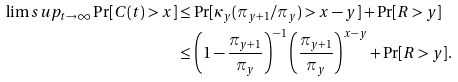<formula> <loc_0><loc_0><loc_500><loc_500>\lim s u p _ { t \to \infty } \Pr [ C ( t ) > x ] & \leq \Pr [ \kappa _ { y } ( \pi _ { y + 1 } / \pi _ { y } ) > x - y ] + \Pr [ R > y ] \\ & \leq \left ( 1 - \frac { \pi _ { y + 1 } } { \pi _ { y } } \right ) ^ { - 1 } \left ( \frac { \pi _ { y + 1 } } { \pi _ { y } } \right ) ^ { x - y } + \Pr [ R > y ] .</formula> 